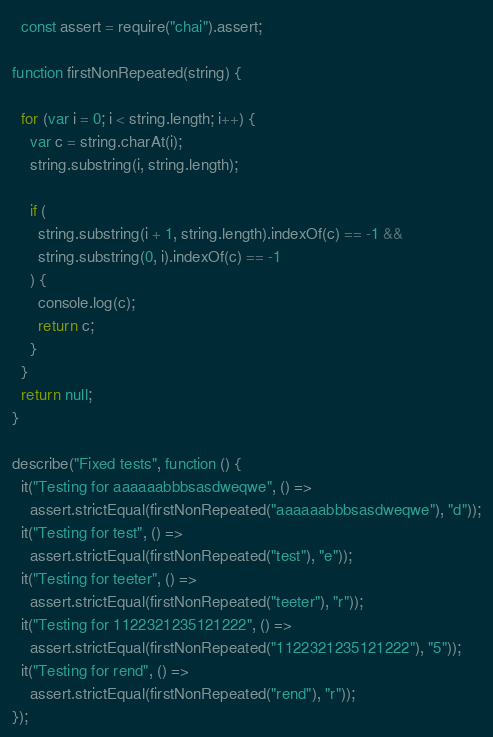Convert code to text. <code><loc_0><loc_0><loc_500><loc_500><_JavaScript_>  const assert = require("chai").assert;

function firstNonRepeated(string) {
    
  for (var i = 0; i < string.length; i++) {
    var c = string.charAt(i);
    string.substring(i, string.length);

    if (
      string.substring(i + 1, string.length).indexOf(c) == -1 &&
      string.substring(0, i).indexOf(c) == -1
    ) {
      console.log(c);
      return c;
    }
  }
  return null;
}

describe("Fixed tests", function () {
  it("Testing for aaaaaabbbsasdweqwe", () =>
    assert.strictEqual(firstNonRepeated("aaaaaabbbsasdweqwe"), "d"));
  it("Testing for test", () =>
    assert.strictEqual(firstNonRepeated("test"), "e"));
  it("Testing for teeter", () =>
    assert.strictEqual(firstNonRepeated("teeter"), "r"));
  it("Testing for 1122321235121222", () =>
    assert.strictEqual(firstNonRepeated("1122321235121222"), "5"));
  it("Testing for rend", () =>
    assert.strictEqual(firstNonRepeated("rend"), "r"));
});
</code> 